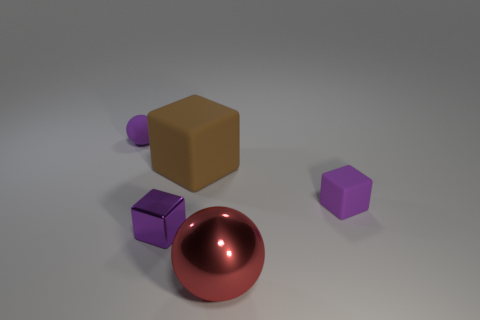Subtract all brown blocks. How many blocks are left? 2 Add 2 purple cubes. How many objects exist? 7 Subtract all purple blocks. How many blocks are left? 1 Subtract 2 balls. How many balls are left? 0 Subtract all blocks. How many objects are left? 2 Add 1 big brown objects. How many big brown objects exist? 2 Subtract 0 cyan balls. How many objects are left? 5 Subtract all brown balls. Subtract all cyan cylinders. How many balls are left? 2 Subtract all blue cylinders. How many brown cubes are left? 1 Subtract all large objects. Subtract all small purple blocks. How many objects are left? 1 